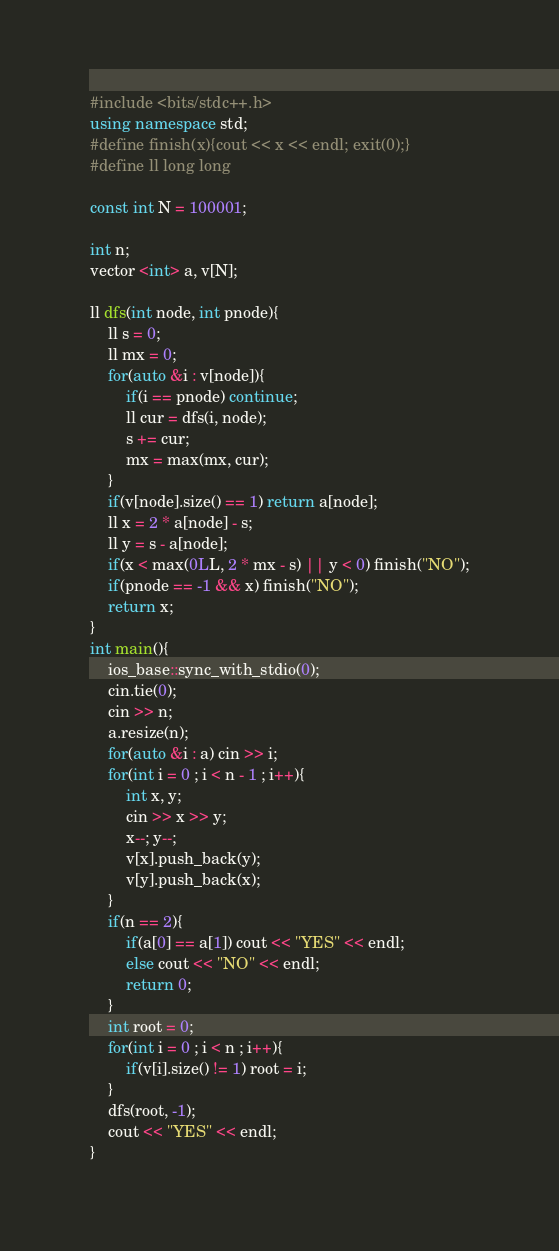<code> <loc_0><loc_0><loc_500><loc_500><_C++_>#include <bits/stdc++.h>
using namespace std;
#define finish(x){cout << x << endl; exit(0);}
#define ll long long

const int N = 100001;

int n;
vector <int> a, v[N];

ll dfs(int node, int pnode){
    ll s = 0;
    ll mx = 0;
    for(auto &i : v[node]){
        if(i == pnode) continue;
        ll cur = dfs(i, node);
        s += cur;
        mx = max(mx, cur);
    }
    if(v[node].size() == 1) return a[node];
    ll x = 2 * a[node] - s;
    ll y = s - a[node];
    if(x < max(0LL, 2 * mx - s) || y < 0) finish("NO");
    if(pnode == -1 && x) finish("NO");
    return x;
}
int main(){
    ios_base::sync_with_stdio(0);
    cin.tie(0);
    cin >> n;
    a.resize(n);
    for(auto &i : a) cin >> i;
    for(int i = 0 ; i < n - 1 ; i++){
        int x, y;
        cin >> x >> y;
        x--; y--;
        v[x].push_back(y);
        v[y].push_back(x);
    }
    if(n == 2){
        if(a[0] == a[1]) cout << "YES" << endl;
        else cout << "NO" << endl;
        return 0;
    }
    int root = 0;
    for(int i = 0 ; i < n ; i++){
        if(v[i].size() != 1) root = i;
    }
    dfs(root, -1);
    cout << "YES" << endl;
}
</code> 